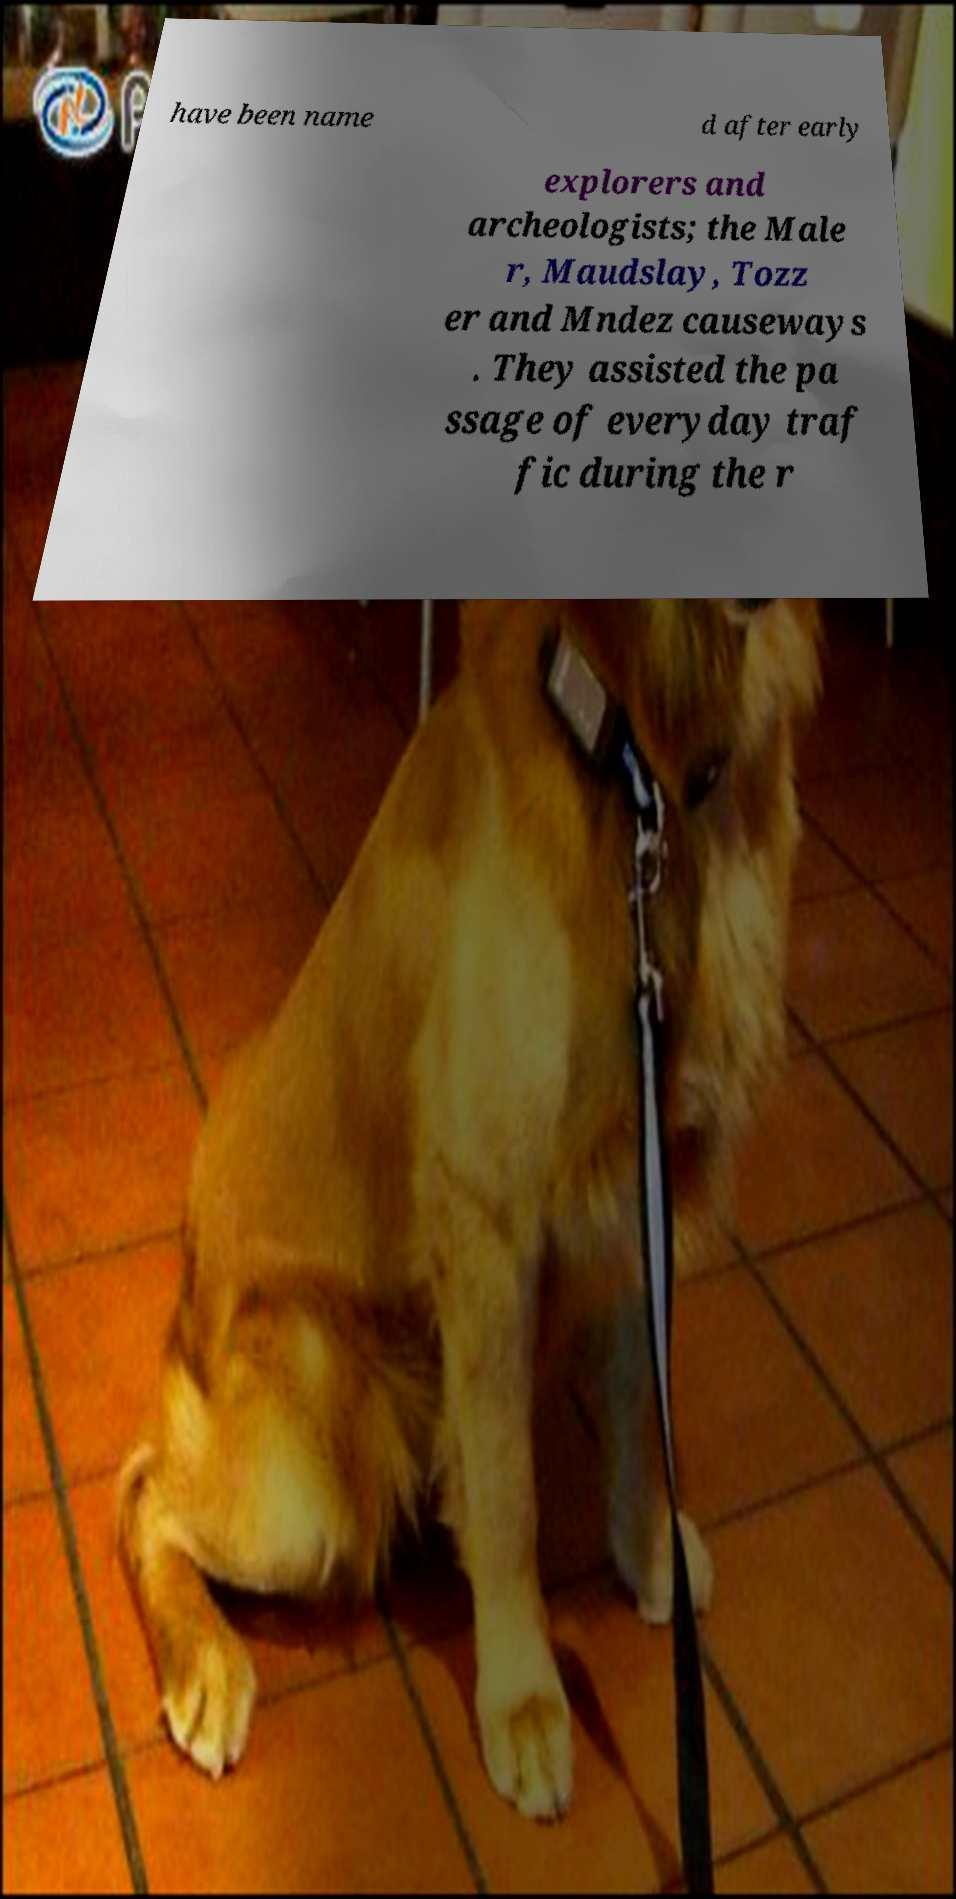Can you accurately transcribe the text from the provided image for me? have been name d after early explorers and archeologists; the Male r, Maudslay, Tozz er and Mndez causeways . They assisted the pa ssage of everyday traf fic during the r 